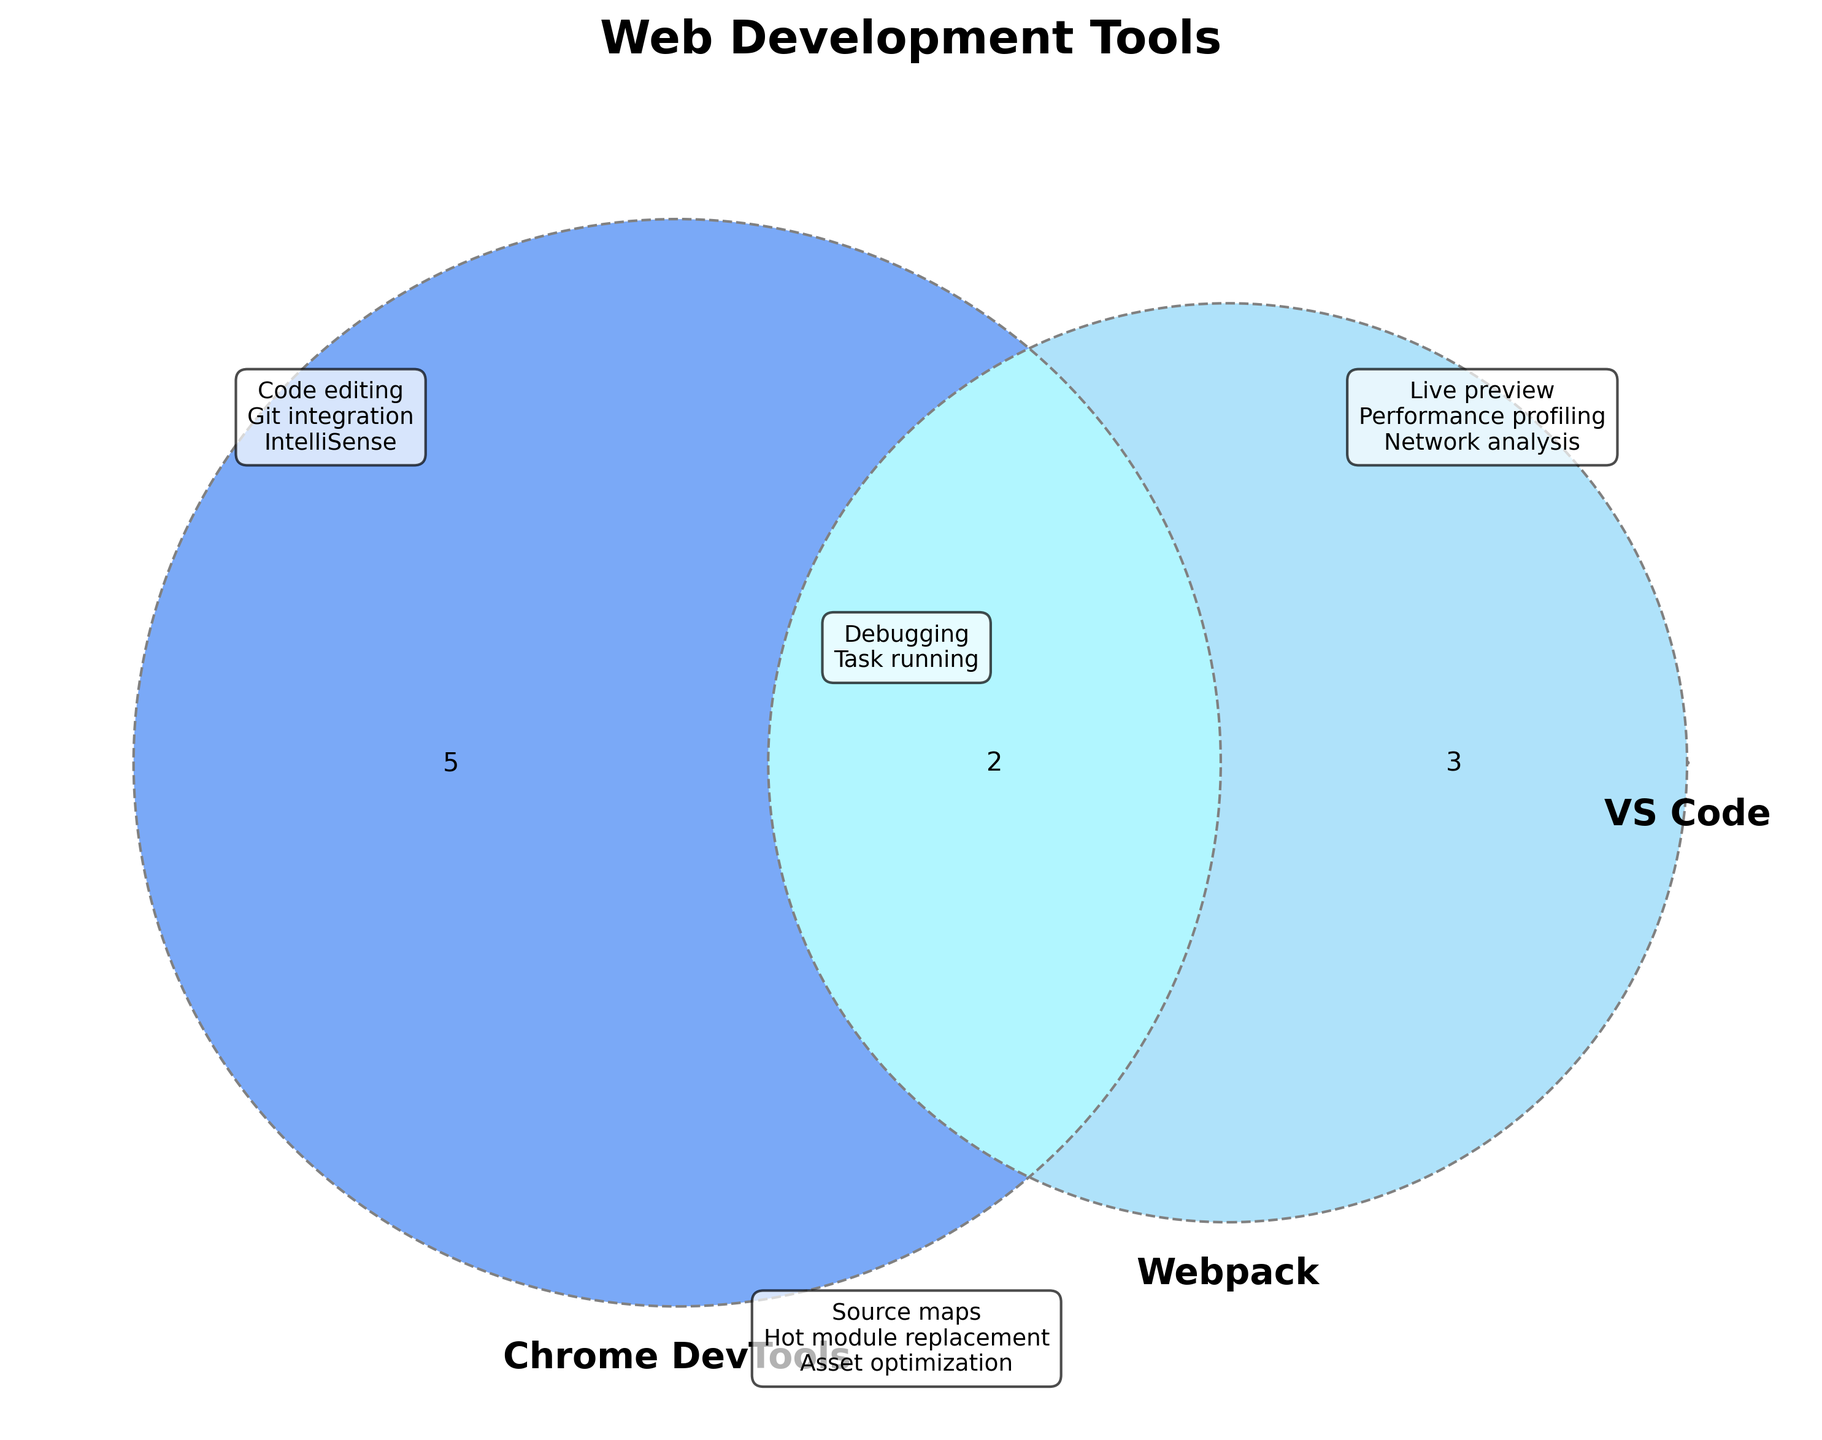Which tools support code editing? Refer to the feature annotations for VS Code, Chrome DevTools, and Webpack. Code editing is listed under VS Code.
Answer: VS Code What features are common between VS Code and Chrome DevTools? Observe the overlap between the circles for VS Code and Chrome DevTools. Debugging and Task running are listed as common features.
Answer: Debugging, Task running Which tool offers performance profiling? Look at the feature annotations for Chrome DevTools. Performance profiling is listed under Chrome DevTools.
Answer: Chrome DevTools What features are unique to Webpack? Refer to the feature annotations for Webpack. Source maps, Hot module replacement, and Asset optimization are listed uniquely under Webpack.
Answer: Source maps, Hot module replacement, Asset optimization Does Webpack have any feature in common with VS Code or Chrome DevTools? Check overlaps involving Webpack with VS Code and Chrome DevTools. Webpack features do not overlap with either.
Answer: No Which tools provide debugging? Debugging is shown in the overlaps between VS Code and Chrome DevTools. Both these tools support debugging.
Answer: VS Code, Chrome DevTools What feature is shared by all three tools? Find the section where all three circles intersect. Source maps, Hot module replacement and Code bundling appear in this intersection.
Answer: None What feature does Chrome DevTools have that VS Code does not? Look at features listed uniquely under Chrome DevTools. Live preview, Performance profiling, and Network analysis are not in VS Code.
Answer: Live preview, Performance profiling, Network analysis Do both VS Code and Webpack have any overlapping features? Check for any section where VS Code and Webpack circles only overlap. There is no overlap between just them.
Answer: No Which tool provides live preview? Refer to the features annotated for Chrome DevTools. Live preview is listed under it.
Answer: Chrome DevTools 